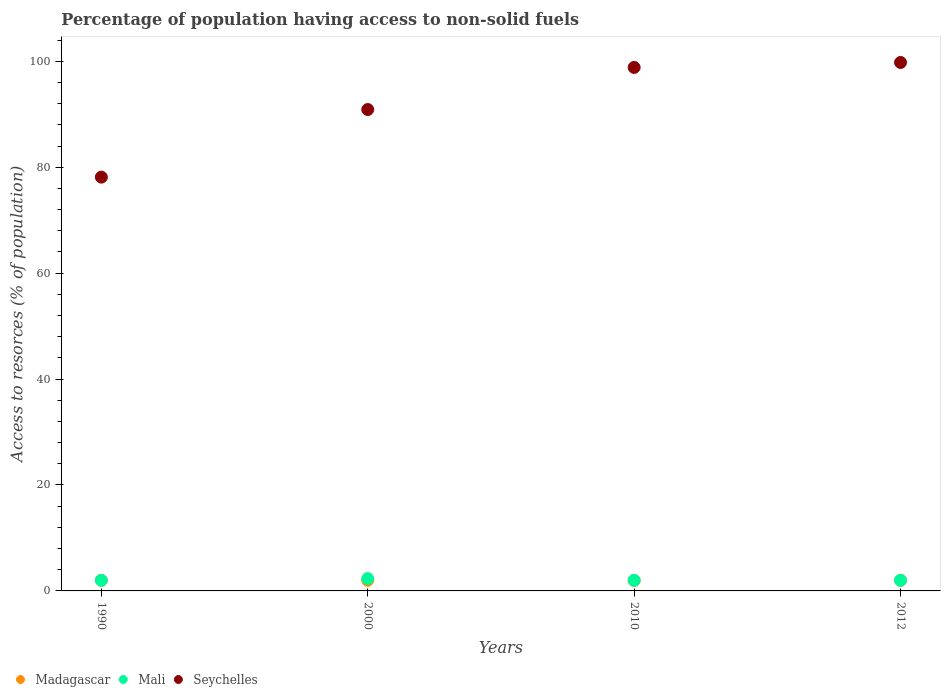How many different coloured dotlines are there?
Offer a very short reply. 3. What is the percentage of population having access to non-solid fuels in Seychelles in 2012?
Your answer should be compact. 99.78. Across all years, what is the maximum percentage of population having access to non-solid fuels in Seychelles?
Provide a succinct answer. 99.78. Across all years, what is the minimum percentage of population having access to non-solid fuels in Madagascar?
Your response must be concise. 2. In which year was the percentage of population having access to non-solid fuels in Seychelles minimum?
Your response must be concise. 1990. What is the total percentage of population having access to non-solid fuels in Seychelles in the graph?
Keep it short and to the point. 367.63. What is the difference between the percentage of population having access to non-solid fuels in Seychelles in 2000 and that in 2012?
Keep it short and to the point. -8.89. What is the difference between the percentage of population having access to non-solid fuels in Seychelles in 2010 and the percentage of population having access to non-solid fuels in Madagascar in 2012?
Offer a terse response. 96.84. What is the average percentage of population having access to non-solid fuels in Mali per year?
Make the answer very short. 2.08. In the year 2012, what is the difference between the percentage of population having access to non-solid fuels in Madagascar and percentage of population having access to non-solid fuels in Seychelles?
Keep it short and to the point. -97.78. What is the ratio of the percentage of population having access to non-solid fuels in Seychelles in 1990 to that in 2010?
Provide a short and direct response. 0.79. Is the percentage of population having access to non-solid fuels in Mali in 2000 less than that in 2012?
Offer a terse response. No. Is the difference between the percentage of population having access to non-solid fuels in Madagascar in 1990 and 2000 greater than the difference between the percentage of population having access to non-solid fuels in Seychelles in 1990 and 2000?
Your answer should be compact. Yes. What is the difference between the highest and the second highest percentage of population having access to non-solid fuels in Seychelles?
Your response must be concise. 0.94. In how many years, is the percentage of population having access to non-solid fuels in Madagascar greater than the average percentage of population having access to non-solid fuels in Madagascar taken over all years?
Your answer should be very brief. 0. Is the percentage of population having access to non-solid fuels in Madagascar strictly greater than the percentage of population having access to non-solid fuels in Mali over the years?
Keep it short and to the point. No. Is the percentage of population having access to non-solid fuels in Seychelles strictly less than the percentage of population having access to non-solid fuels in Madagascar over the years?
Ensure brevity in your answer.  No. What is the difference between two consecutive major ticks on the Y-axis?
Your answer should be compact. 20. Are the values on the major ticks of Y-axis written in scientific E-notation?
Keep it short and to the point. No. Does the graph contain grids?
Your answer should be compact. No. Where does the legend appear in the graph?
Offer a very short reply. Bottom left. How many legend labels are there?
Keep it short and to the point. 3. What is the title of the graph?
Ensure brevity in your answer.  Percentage of population having access to non-solid fuels. What is the label or title of the Y-axis?
Ensure brevity in your answer.  Access to resorces (% of population). What is the Access to resorces (% of population) in Madagascar in 1990?
Offer a terse response. 2. What is the Access to resorces (% of population) in Mali in 1990?
Keep it short and to the point. 2. What is the Access to resorces (% of population) in Seychelles in 1990?
Your answer should be very brief. 78.13. What is the Access to resorces (% of population) in Madagascar in 2000?
Provide a succinct answer. 2. What is the Access to resorces (% of population) in Mali in 2000?
Provide a succinct answer. 2.34. What is the Access to resorces (% of population) of Seychelles in 2000?
Offer a terse response. 90.89. What is the Access to resorces (% of population) of Madagascar in 2010?
Ensure brevity in your answer.  2. What is the Access to resorces (% of population) in Mali in 2010?
Keep it short and to the point. 2. What is the Access to resorces (% of population) of Seychelles in 2010?
Provide a short and direct response. 98.84. What is the Access to resorces (% of population) of Madagascar in 2012?
Offer a terse response. 2. What is the Access to resorces (% of population) in Mali in 2012?
Provide a short and direct response. 2. What is the Access to resorces (% of population) of Seychelles in 2012?
Offer a terse response. 99.78. Across all years, what is the maximum Access to resorces (% of population) of Madagascar?
Your answer should be compact. 2. Across all years, what is the maximum Access to resorces (% of population) of Mali?
Provide a short and direct response. 2.34. Across all years, what is the maximum Access to resorces (% of population) in Seychelles?
Give a very brief answer. 99.78. Across all years, what is the minimum Access to resorces (% of population) in Madagascar?
Your response must be concise. 2. Across all years, what is the minimum Access to resorces (% of population) of Mali?
Provide a short and direct response. 2. Across all years, what is the minimum Access to resorces (% of population) in Seychelles?
Ensure brevity in your answer.  78.13. What is the total Access to resorces (% of population) of Mali in the graph?
Ensure brevity in your answer.  8.34. What is the total Access to resorces (% of population) in Seychelles in the graph?
Your answer should be compact. 367.63. What is the difference between the Access to resorces (% of population) of Mali in 1990 and that in 2000?
Keep it short and to the point. -0.34. What is the difference between the Access to resorces (% of population) of Seychelles in 1990 and that in 2000?
Keep it short and to the point. -12.76. What is the difference between the Access to resorces (% of population) of Madagascar in 1990 and that in 2010?
Offer a very short reply. 0. What is the difference between the Access to resorces (% of population) in Seychelles in 1990 and that in 2010?
Your answer should be very brief. -20.71. What is the difference between the Access to resorces (% of population) of Seychelles in 1990 and that in 2012?
Keep it short and to the point. -21.65. What is the difference between the Access to resorces (% of population) of Madagascar in 2000 and that in 2010?
Your response must be concise. 0. What is the difference between the Access to resorces (% of population) of Mali in 2000 and that in 2010?
Your response must be concise. 0.34. What is the difference between the Access to resorces (% of population) in Seychelles in 2000 and that in 2010?
Keep it short and to the point. -7.95. What is the difference between the Access to resorces (% of population) of Madagascar in 2000 and that in 2012?
Your answer should be very brief. 0. What is the difference between the Access to resorces (% of population) in Mali in 2000 and that in 2012?
Provide a short and direct response. 0.34. What is the difference between the Access to resorces (% of population) of Seychelles in 2000 and that in 2012?
Provide a succinct answer. -8.89. What is the difference between the Access to resorces (% of population) of Madagascar in 2010 and that in 2012?
Make the answer very short. 0. What is the difference between the Access to resorces (% of population) of Mali in 2010 and that in 2012?
Make the answer very short. 0. What is the difference between the Access to resorces (% of population) of Seychelles in 2010 and that in 2012?
Keep it short and to the point. -0.94. What is the difference between the Access to resorces (% of population) of Madagascar in 1990 and the Access to resorces (% of population) of Mali in 2000?
Provide a succinct answer. -0.34. What is the difference between the Access to resorces (% of population) in Madagascar in 1990 and the Access to resorces (% of population) in Seychelles in 2000?
Your response must be concise. -88.89. What is the difference between the Access to resorces (% of population) of Mali in 1990 and the Access to resorces (% of population) of Seychelles in 2000?
Give a very brief answer. -88.89. What is the difference between the Access to resorces (% of population) in Madagascar in 1990 and the Access to resorces (% of population) in Seychelles in 2010?
Your answer should be compact. -96.84. What is the difference between the Access to resorces (% of population) of Mali in 1990 and the Access to resorces (% of population) of Seychelles in 2010?
Offer a terse response. -96.84. What is the difference between the Access to resorces (% of population) of Madagascar in 1990 and the Access to resorces (% of population) of Mali in 2012?
Give a very brief answer. 0. What is the difference between the Access to resorces (% of population) in Madagascar in 1990 and the Access to resorces (% of population) in Seychelles in 2012?
Provide a succinct answer. -97.78. What is the difference between the Access to resorces (% of population) in Mali in 1990 and the Access to resorces (% of population) in Seychelles in 2012?
Give a very brief answer. -97.78. What is the difference between the Access to resorces (% of population) in Madagascar in 2000 and the Access to resorces (% of population) in Seychelles in 2010?
Provide a short and direct response. -96.84. What is the difference between the Access to resorces (% of population) in Mali in 2000 and the Access to resorces (% of population) in Seychelles in 2010?
Make the answer very short. -96.5. What is the difference between the Access to resorces (% of population) in Madagascar in 2000 and the Access to resorces (% of population) in Seychelles in 2012?
Your answer should be compact. -97.78. What is the difference between the Access to resorces (% of population) in Mali in 2000 and the Access to resorces (% of population) in Seychelles in 2012?
Provide a succinct answer. -97.44. What is the difference between the Access to resorces (% of population) of Madagascar in 2010 and the Access to resorces (% of population) of Seychelles in 2012?
Give a very brief answer. -97.78. What is the difference between the Access to resorces (% of population) of Mali in 2010 and the Access to resorces (% of population) of Seychelles in 2012?
Your answer should be very brief. -97.78. What is the average Access to resorces (% of population) of Mali per year?
Your response must be concise. 2.08. What is the average Access to resorces (% of population) of Seychelles per year?
Your answer should be very brief. 91.91. In the year 1990, what is the difference between the Access to resorces (% of population) of Madagascar and Access to resorces (% of population) of Mali?
Your answer should be very brief. 0. In the year 1990, what is the difference between the Access to resorces (% of population) of Madagascar and Access to resorces (% of population) of Seychelles?
Offer a very short reply. -76.13. In the year 1990, what is the difference between the Access to resorces (% of population) in Mali and Access to resorces (% of population) in Seychelles?
Your response must be concise. -76.13. In the year 2000, what is the difference between the Access to resorces (% of population) of Madagascar and Access to resorces (% of population) of Mali?
Provide a succinct answer. -0.34. In the year 2000, what is the difference between the Access to resorces (% of population) of Madagascar and Access to resorces (% of population) of Seychelles?
Your answer should be compact. -88.89. In the year 2000, what is the difference between the Access to resorces (% of population) in Mali and Access to resorces (% of population) in Seychelles?
Ensure brevity in your answer.  -88.55. In the year 2010, what is the difference between the Access to resorces (% of population) in Madagascar and Access to resorces (% of population) in Seychelles?
Give a very brief answer. -96.84. In the year 2010, what is the difference between the Access to resorces (% of population) in Mali and Access to resorces (% of population) in Seychelles?
Provide a short and direct response. -96.84. In the year 2012, what is the difference between the Access to resorces (% of population) of Madagascar and Access to resorces (% of population) of Seychelles?
Offer a very short reply. -97.78. In the year 2012, what is the difference between the Access to resorces (% of population) in Mali and Access to resorces (% of population) in Seychelles?
Make the answer very short. -97.78. What is the ratio of the Access to resorces (% of population) of Madagascar in 1990 to that in 2000?
Your answer should be very brief. 1. What is the ratio of the Access to resorces (% of population) in Mali in 1990 to that in 2000?
Your answer should be compact. 0.86. What is the ratio of the Access to resorces (% of population) in Seychelles in 1990 to that in 2000?
Your answer should be very brief. 0.86. What is the ratio of the Access to resorces (% of population) of Seychelles in 1990 to that in 2010?
Make the answer very short. 0.79. What is the ratio of the Access to resorces (% of population) in Mali in 1990 to that in 2012?
Make the answer very short. 1. What is the ratio of the Access to resorces (% of population) of Seychelles in 1990 to that in 2012?
Offer a terse response. 0.78. What is the ratio of the Access to resorces (% of population) in Mali in 2000 to that in 2010?
Provide a succinct answer. 1.17. What is the ratio of the Access to resorces (% of population) of Seychelles in 2000 to that in 2010?
Ensure brevity in your answer.  0.92. What is the ratio of the Access to resorces (% of population) in Madagascar in 2000 to that in 2012?
Make the answer very short. 1. What is the ratio of the Access to resorces (% of population) in Mali in 2000 to that in 2012?
Make the answer very short. 1.17. What is the ratio of the Access to resorces (% of population) in Seychelles in 2000 to that in 2012?
Offer a very short reply. 0.91. What is the ratio of the Access to resorces (% of population) of Madagascar in 2010 to that in 2012?
Offer a terse response. 1. What is the ratio of the Access to resorces (% of population) of Seychelles in 2010 to that in 2012?
Your response must be concise. 0.99. What is the difference between the highest and the second highest Access to resorces (% of population) in Madagascar?
Provide a succinct answer. 0. What is the difference between the highest and the second highest Access to resorces (% of population) in Mali?
Your response must be concise. 0.34. What is the difference between the highest and the second highest Access to resorces (% of population) of Seychelles?
Give a very brief answer. 0.94. What is the difference between the highest and the lowest Access to resorces (% of population) of Madagascar?
Your answer should be compact. 0. What is the difference between the highest and the lowest Access to resorces (% of population) in Mali?
Your answer should be very brief. 0.34. What is the difference between the highest and the lowest Access to resorces (% of population) in Seychelles?
Offer a very short reply. 21.65. 